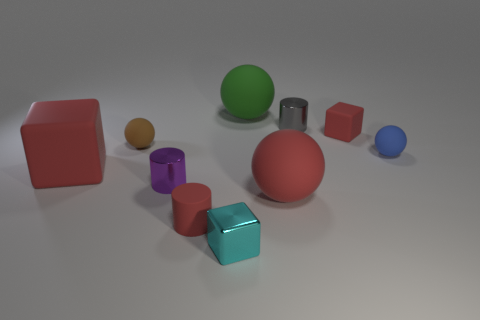Is the color of the small matte cube the same as the big matte block?
Make the answer very short. Yes. There is a red matte object that is to the left of the brown sphere; does it have the same size as the red matte cube that is behind the tiny blue matte ball?
Offer a terse response. No. The large rubber thing that is behind the blue matte ball has what shape?
Provide a short and direct response. Sphere. The large rubber cube is what color?
Your answer should be very brief. Red. There is a gray thing; is its size the same as the rubber sphere in front of the blue object?
Provide a succinct answer. No. How many rubber things are large red objects or spheres?
Give a very brief answer. 5. Are there any other things that have the same material as the blue sphere?
Offer a terse response. Yes. There is a large cube; is its color the same as the large sphere in front of the green rubber thing?
Offer a terse response. Yes. What is the shape of the gray object?
Offer a very short reply. Cylinder. There is a blue rubber ball behind the tiny red thing on the left side of the tiny cylinder that is to the right of the shiny cube; what size is it?
Make the answer very short. Small. 